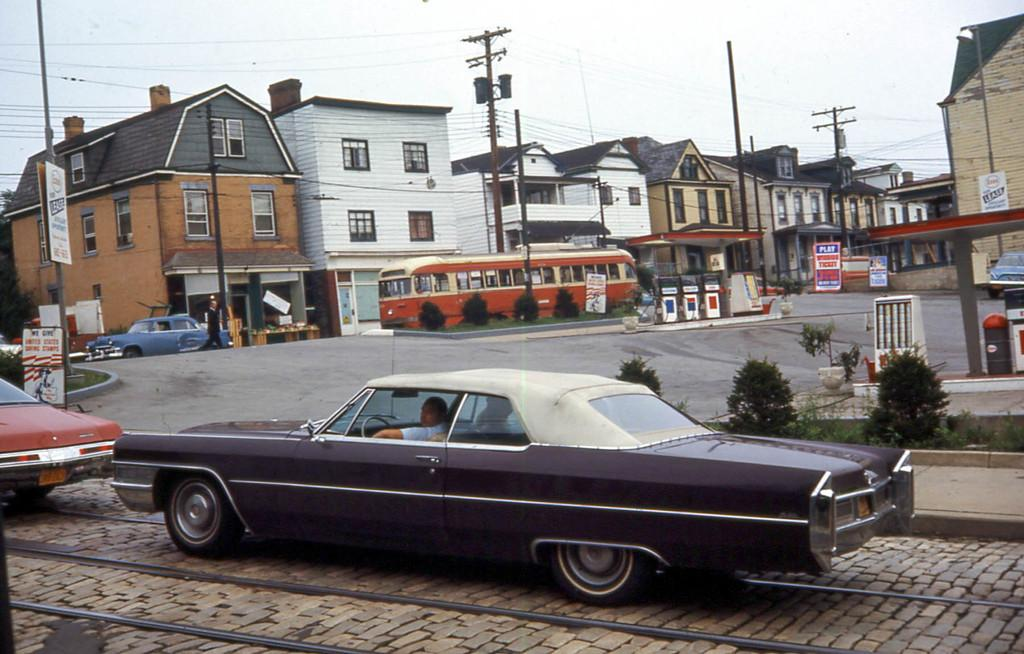What type of vehicles can be seen in the image? There are cars and a bus in the image. What else is present in the image besides vehicles? There are poles and buildings in the image. Can you tell me how many giraffes are standing near the buildings in the image? There are no giraffes present in the image; it features cars, a bus, poles, and buildings. 